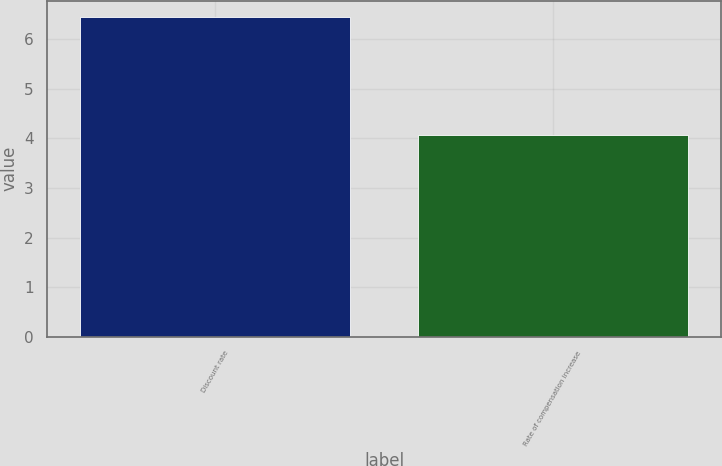Convert chart. <chart><loc_0><loc_0><loc_500><loc_500><bar_chart><fcel>Discount rate<fcel>Rate of compensation increase<nl><fcel>6.45<fcel>4.06<nl></chart> 